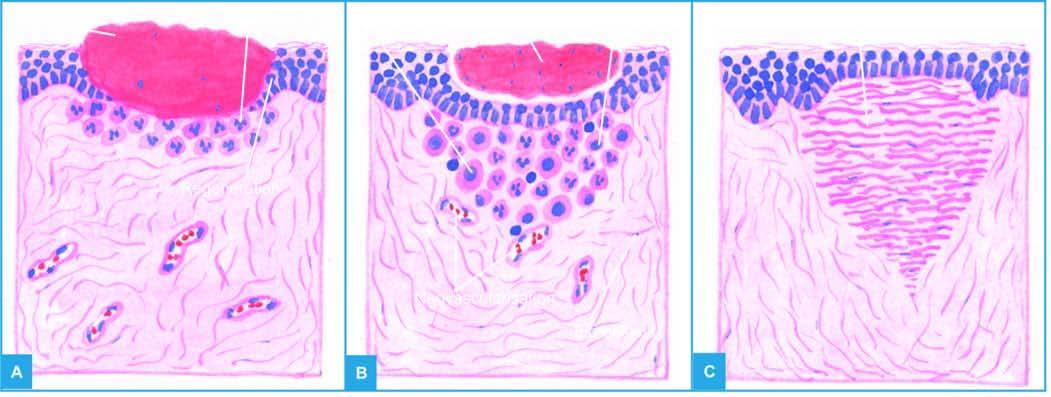s section of matted mass of lymph nodes left after contraction of the wound?
Answer the question using a single word or phrase. No 